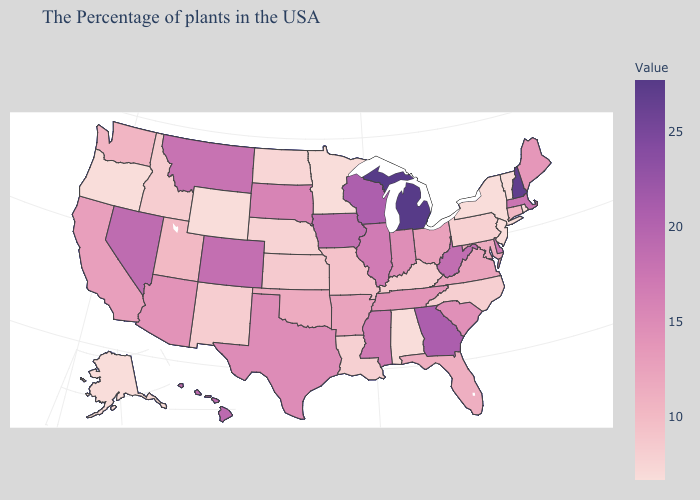Does Michigan have the highest value in the USA?
Answer briefly. Yes. Which states have the lowest value in the USA?
Answer briefly. Rhode Island, Vermont, New York, New Jersey, Alabama, Minnesota, Wyoming, Oregon, Alaska. Among the states that border Utah , does Arizona have the highest value?
Quick response, please. No. Is the legend a continuous bar?
Keep it brief. Yes. Among the states that border Alabama , which have the lowest value?
Quick response, please. Florida. Which states have the lowest value in the USA?
Keep it brief. Rhode Island, Vermont, New York, New Jersey, Alabama, Minnesota, Wyoming, Oregon, Alaska. 